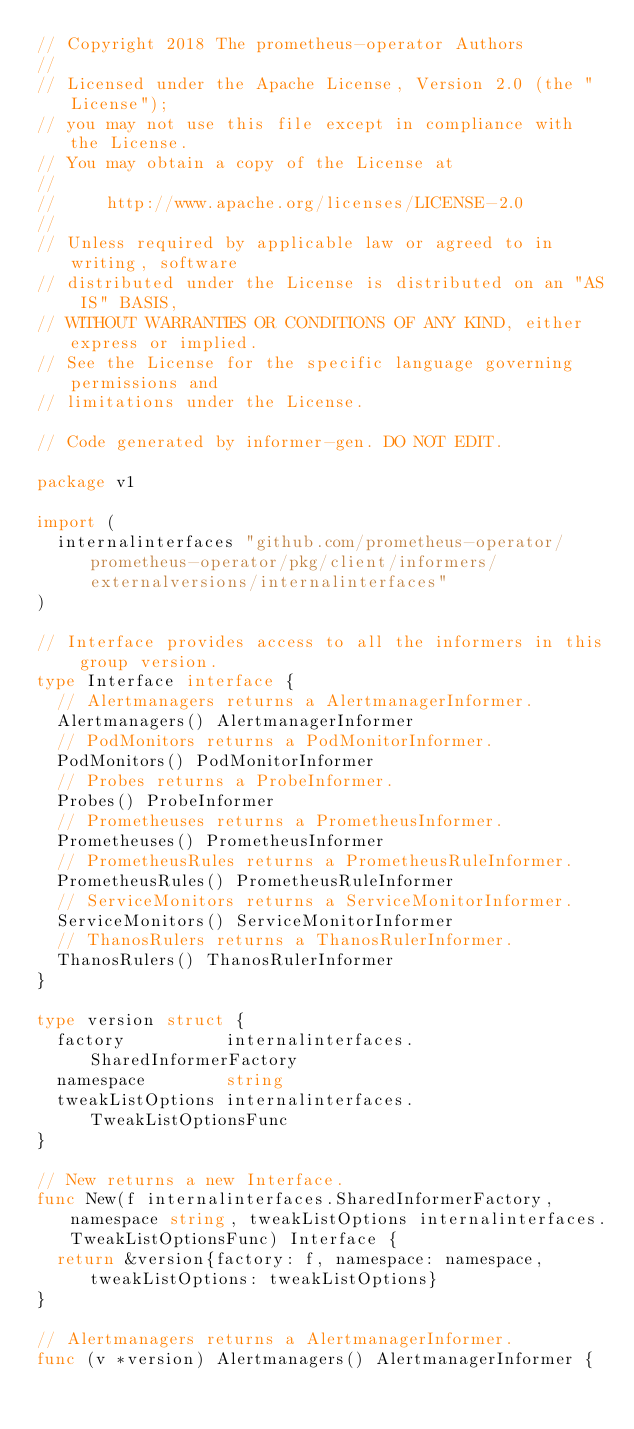<code> <loc_0><loc_0><loc_500><loc_500><_Go_>// Copyright 2018 The prometheus-operator Authors
//
// Licensed under the Apache License, Version 2.0 (the "License");
// you may not use this file except in compliance with the License.
// You may obtain a copy of the License at
//
//     http://www.apache.org/licenses/LICENSE-2.0
//
// Unless required by applicable law or agreed to in writing, software
// distributed under the License is distributed on an "AS IS" BASIS,
// WITHOUT WARRANTIES OR CONDITIONS OF ANY KIND, either express or implied.
// See the License for the specific language governing permissions and
// limitations under the License.

// Code generated by informer-gen. DO NOT EDIT.

package v1

import (
	internalinterfaces "github.com/prometheus-operator/prometheus-operator/pkg/client/informers/externalversions/internalinterfaces"
)

// Interface provides access to all the informers in this group version.
type Interface interface {
	// Alertmanagers returns a AlertmanagerInformer.
	Alertmanagers() AlertmanagerInformer
	// PodMonitors returns a PodMonitorInformer.
	PodMonitors() PodMonitorInformer
	// Probes returns a ProbeInformer.
	Probes() ProbeInformer
	// Prometheuses returns a PrometheusInformer.
	Prometheuses() PrometheusInformer
	// PrometheusRules returns a PrometheusRuleInformer.
	PrometheusRules() PrometheusRuleInformer
	// ServiceMonitors returns a ServiceMonitorInformer.
	ServiceMonitors() ServiceMonitorInformer
	// ThanosRulers returns a ThanosRulerInformer.
	ThanosRulers() ThanosRulerInformer
}

type version struct {
	factory          internalinterfaces.SharedInformerFactory
	namespace        string
	tweakListOptions internalinterfaces.TweakListOptionsFunc
}

// New returns a new Interface.
func New(f internalinterfaces.SharedInformerFactory, namespace string, tweakListOptions internalinterfaces.TweakListOptionsFunc) Interface {
	return &version{factory: f, namespace: namespace, tweakListOptions: tweakListOptions}
}

// Alertmanagers returns a AlertmanagerInformer.
func (v *version) Alertmanagers() AlertmanagerInformer {</code> 